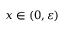<formula> <loc_0><loc_0><loc_500><loc_500>x \in ( 0 , \varepsilon )</formula> 